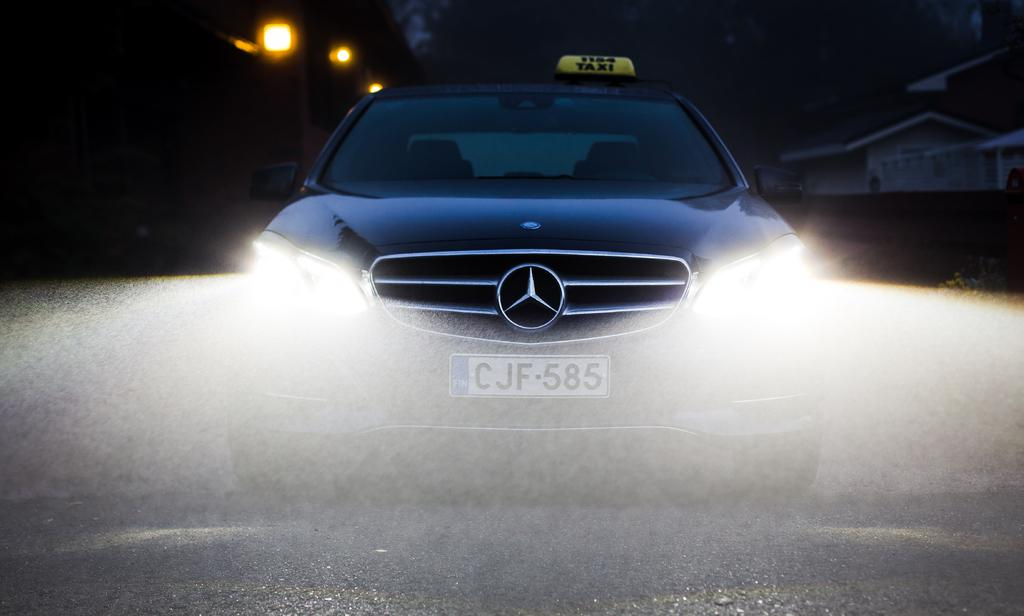What color is the car in the image? The car in the image is blue. What features does the car have? The car has lights. What is the car's number plate? The car's number plate is CJF-585. Can you describe the lighting conditions in the image? The image is a little dark. What time is displayed on the clock in the image? There is no clock present in the image. How many prints are visible on the car's exterior? There is no mention of prints on the car's exterior in the provided facts. 